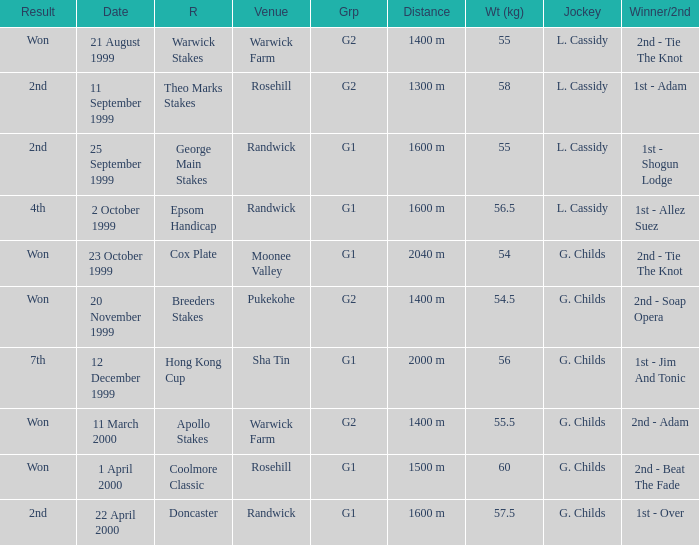List the weight for 56 kilograms. 2000 m. 